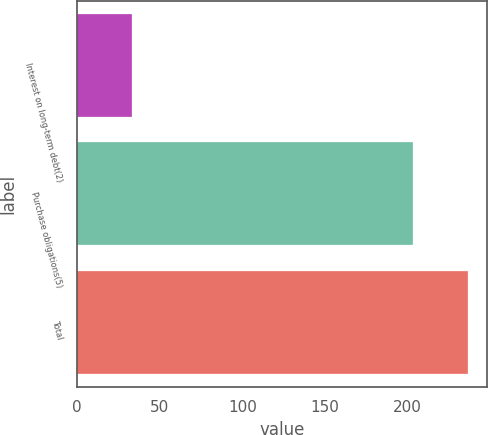Convert chart. <chart><loc_0><loc_0><loc_500><loc_500><bar_chart><fcel>Interest on long-term debt(2)<fcel>Purchase obligations(5)<fcel>Total<nl><fcel>33.1<fcel>203.1<fcel>236.2<nl></chart> 